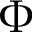Convert formula to latex. <formula><loc_0><loc_0><loc_500><loc_500>\Phi</formula> 